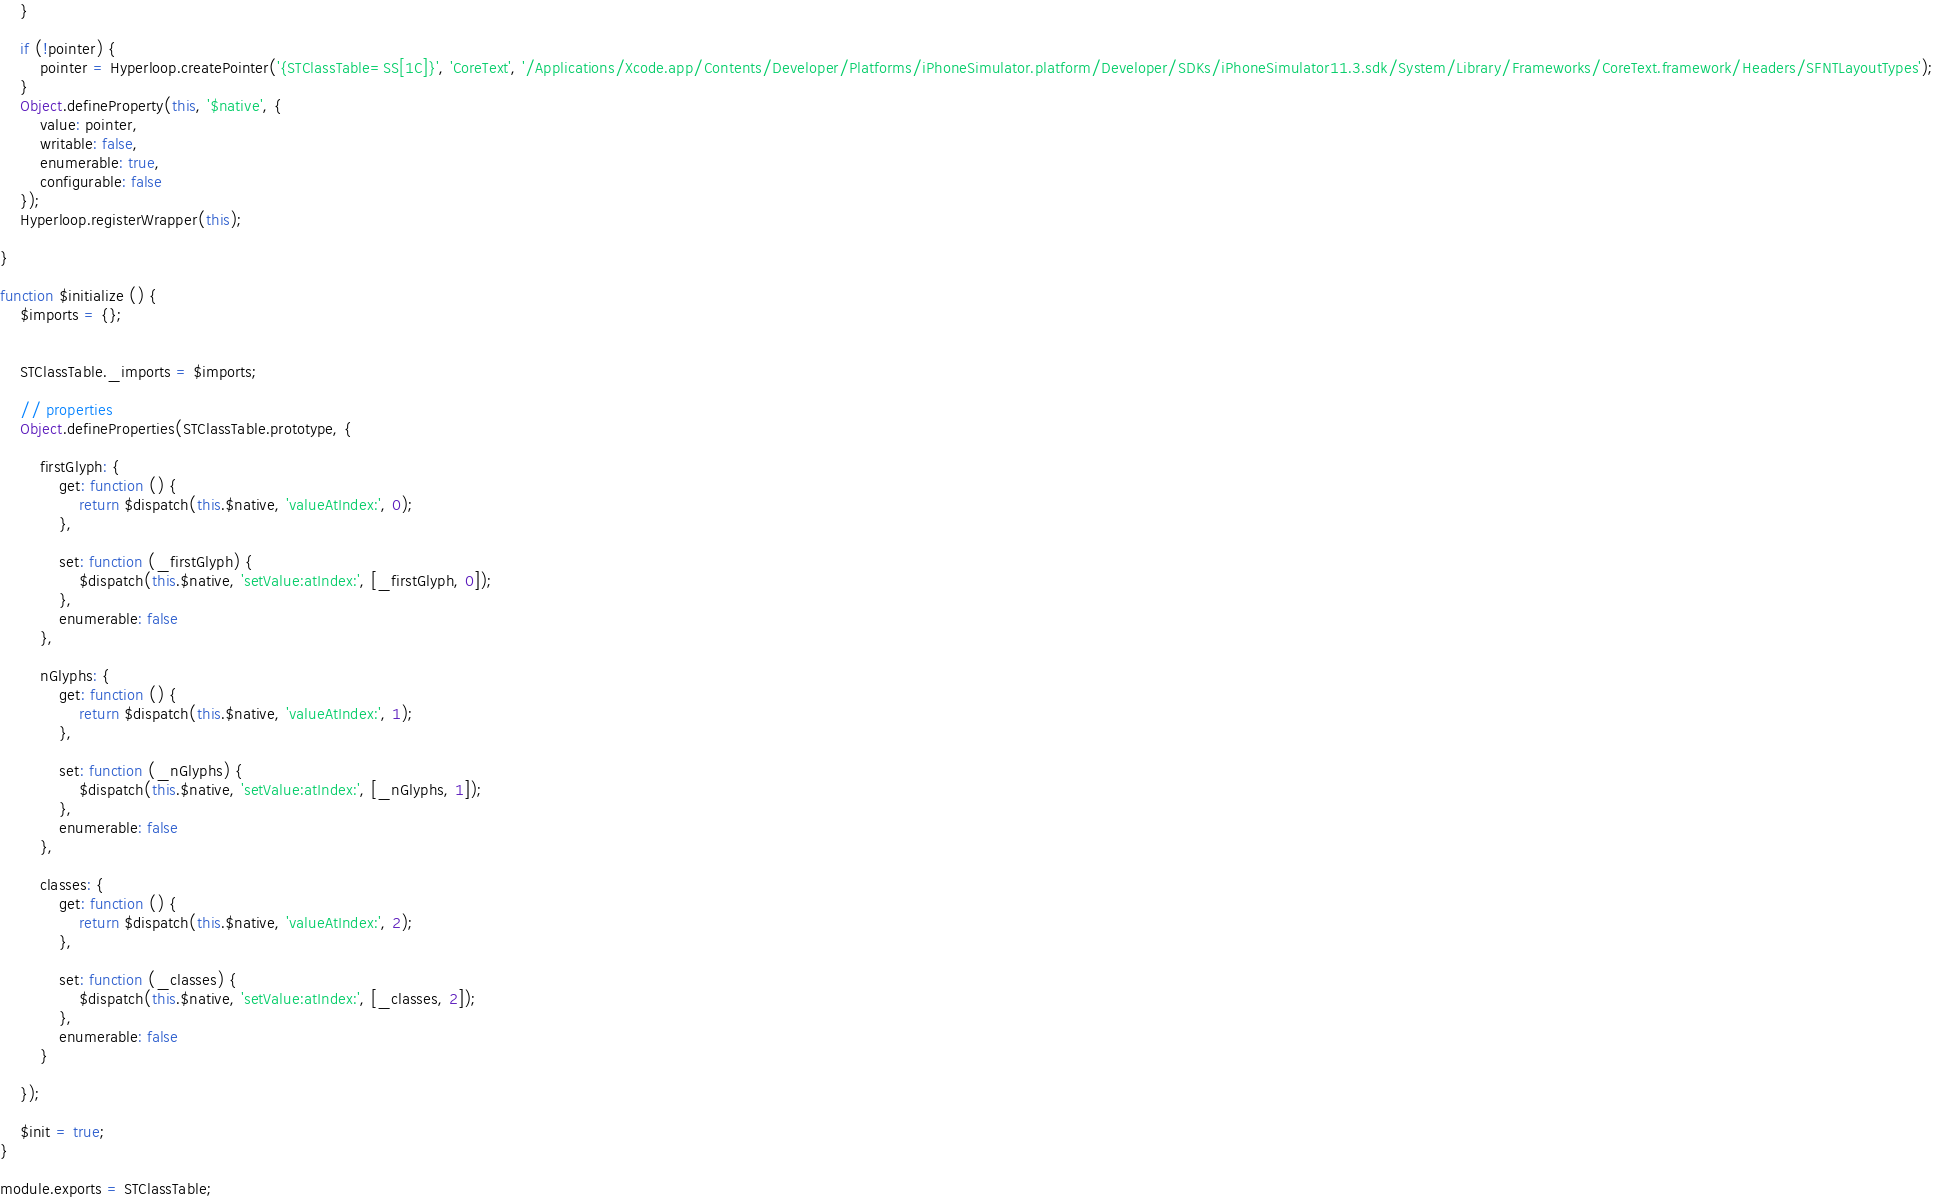<code> <loc_0><loc_0><loc_500><loc_500><_JavaScript_>	}
	
	if (!pointer) {
		pointer = Hyperloop.createPointer('{STClassTable=SS[1C]}', 'CoreText', '/Applications/Xcode.app/Contents/Developer/Platforms/iPhoneSimulator.platform/Developer/SDKs/iPhoneSimulator11.3.sdk/System/Library/Frameworks/CoreText.framework/Headers/SFNTLayoutTypes');
	}
	Object.defineProperty(this, '$native', {
		value: pointer,
		writable: false,
		enumerable: true, 
		configurable: false
	});
	Hyperloop.registerWrapper(this);
	
}

function $initialize () {
	$imports = {};


	STClassTable._imports = $imports;

	// properties
	Object.defineProperties(STClassTable.prototype, {
	
		firstGlyph: {
			get: function () {
				return $dispatch(this.$native, 'valueAtIndex:', 0);
			},
		
			set: function (_firstGlyph) {
				$dispatch(this.$native, 'setValue:atIndex:', [_firstGlyph, 0]);
			},
			enumerable: false
		},
	
		nGlyphs: {
			get: function () {
				return $dispatch(this.$native, 'valueAtIndex:', 1);
			},
		
			set: function (_nGlyphs) {
				$dispatch(this.$native, 'setValue:atIndex:', [_nGlyphs, 1]);
			},
			enumerable: false
		},
	
		classes: {
			get: function () {
				return $dispatch(this.$native, 'valueAtIndex:', 2);
			},
		
			set: function (_classes) {
				$dispatch(this.$native, 'setValue:atIndex:', [_classes, 2]);
			},
			enumerable: false
		}
	
	});

	$init = true;
}

module.exports = STClassTable;
</code> 